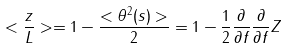Convert formula to latex. <formula><loc_0><loc_0><loc_500><loc_500>< \frac { z } { L } > = 1 - \frac { < \theta ^ { 2 } ( s ) > } { 2 } = 1 - \frac { 1 } { 2 } \frac { \partial } { \partial f } \frac { \partial } { \partial f } Z</formula> 